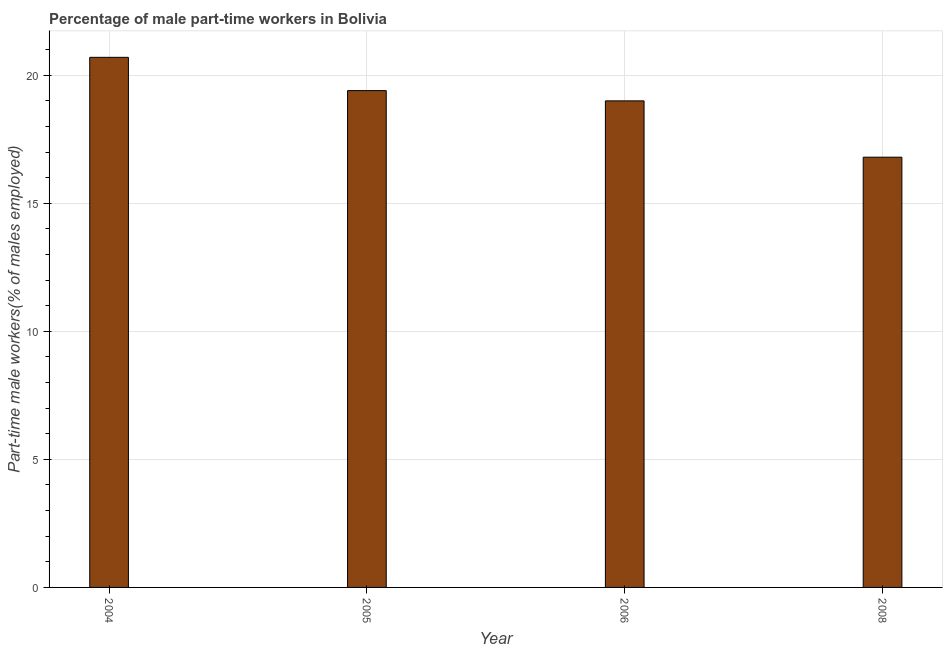Does the graph contain any zero values?
Make the answer very short. No. Does the graph contain grids?
Offer a very short reply. Yes. What is the title of the graph?
Give a very brief answer. Percentage of male part-time workers in Bolivia. What is the label or title of the X-axis?
Your answer should be compact. Year. What is the label or title of the Y-axis?
Ensure brevity in your answer.  Part-time male workers(% of males employed). What is the percentage of part-time male workers in 2004?
Provide a succinct answer. 20.7. Across all years, what is the maximum percentage of part-time male workers?
Ensure brevity in your answer.  20.7. Across all years, what is the minimum percentage of part-time male workers?
Your response must be concise. 16.8. In which year was the percentage of part-time male workers maximum?
Give a very brief answer. 2004. What is the sum of the percentage of part-time male workers?
Provide a short and direct response. 75.9. What is the difference between the percentage of part-time male workers in 2004 and 2006?
Offer a terse response. 1.7. What is the average percentage of part-time male workers per year?
Offer a terse response. 18.98. What is the median percentage of part-time male workers?
Your answer should be very brief. 19.2. Do a majority of the years between 2006 and 2004 (inclusive) have percentage of part-time male workers greater than 12 %?
Make the answer very short. Yes. What is the ratio of the percentage of part-time male workers in 2005 to that in 2008?
Give a very brief answer. 1.16. Is the difference between the percentage of part-time male workers in 2005 and 2008 greater than the difference between any two years?
Provide a short and direct response. No. What is the difference between the highest and the second highest percentage of part-time male workers?
Provide a succinct answer. 1.3. Is the sum of the percentage of part-time male workers in 2005 and 2008 greater than the maximum percentage of part-time male workers across all years?
Your response must be concise. Yes. How many bars are there?
Give a very brief answer. 4. How many years are there in the graph?
Ensure brevity in your answer.  4. Are the values on the major ticks of Y-axis written in scientific E-notation?
Your answer should be very brief. No. What is the Part-time male workers(% of males employed) in 2004?
Your response must be concise. 20.7. What is the Part-time male workers(% of males employed) in 2005?
Ensure brevity in your answer.  19.4. What is the Part-time male workers(% of males employed) of 2006?
Offer a very short reply. 19. What is the Part-time male workers(% of males employed) of 2008?
Make the answer very short. 16.8. What is the difference between the Part-time male workers(% of males employed) in 2004 and 2006?
Provide a short and direct response. 1.7. What is the difference between the Part-time male workers(% of males employed) in 2005 and 2006?
Offer a very short reply. 0.4. What is the difference between the Part-time male workers(% of males employed) in 2005 and 2008?
Your answer should be very brief. 2.6. What is the ratio of the Part-time male workers(% of males employed) in 2004 to that in 2005?
Offer a terse response. 1.07. What is the ratio of the Part-time male workers(% of males employed) in 2004 to that in 2006?
Your response must be concise. 1.09. What is the ratio of the Part-time male workers(% of males employed) in 2004 to that in 2008?
Give a very brief answer. 1.23. What is the ratio of the Part-time male workers(% of males employed) in 2005 to that in 2006?
Your response must be concise. 1.02. What is the ratio of the Part-time male workers(% of males employed) in 2005 to that in 2008?
Offer a very short reply. 1.16. What is the ratio of the Part-time male workers(% of males employed) in 2006 to that in 2008?
Your response must be concise. 1.13. 